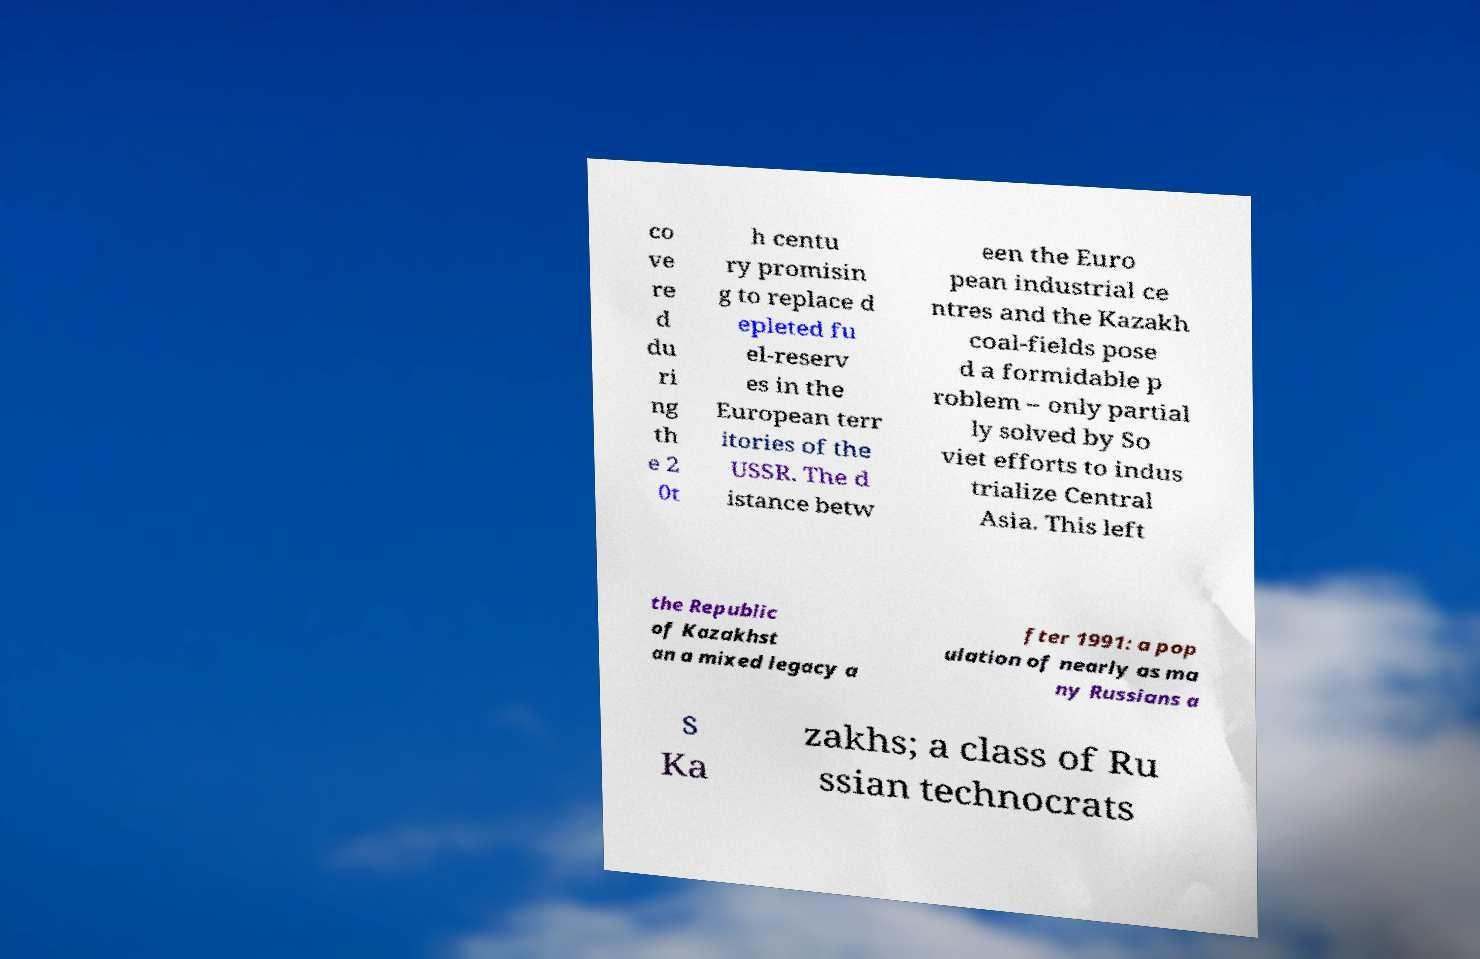Could you assist in decoding the text presented in this image and type it out clearly? co ve re d du ri ng th e 2 0t h centu ry promisin g to replace d epleted fu el-reserv es in the European terr itories of the USSR. The d istance betw een the Euro pean industrial ce ntres and the Kazakh coal-fields pose d a formidable p roblem – only partial ly solved by So viet efforts to indus trialize Central Asia. This left the Republic of Kazakhst an a mixed legacy a fter 1991: a pop ulation of nearly as ma ny Russians a s Ka zakhs; a class of Ru ssian technocrats 